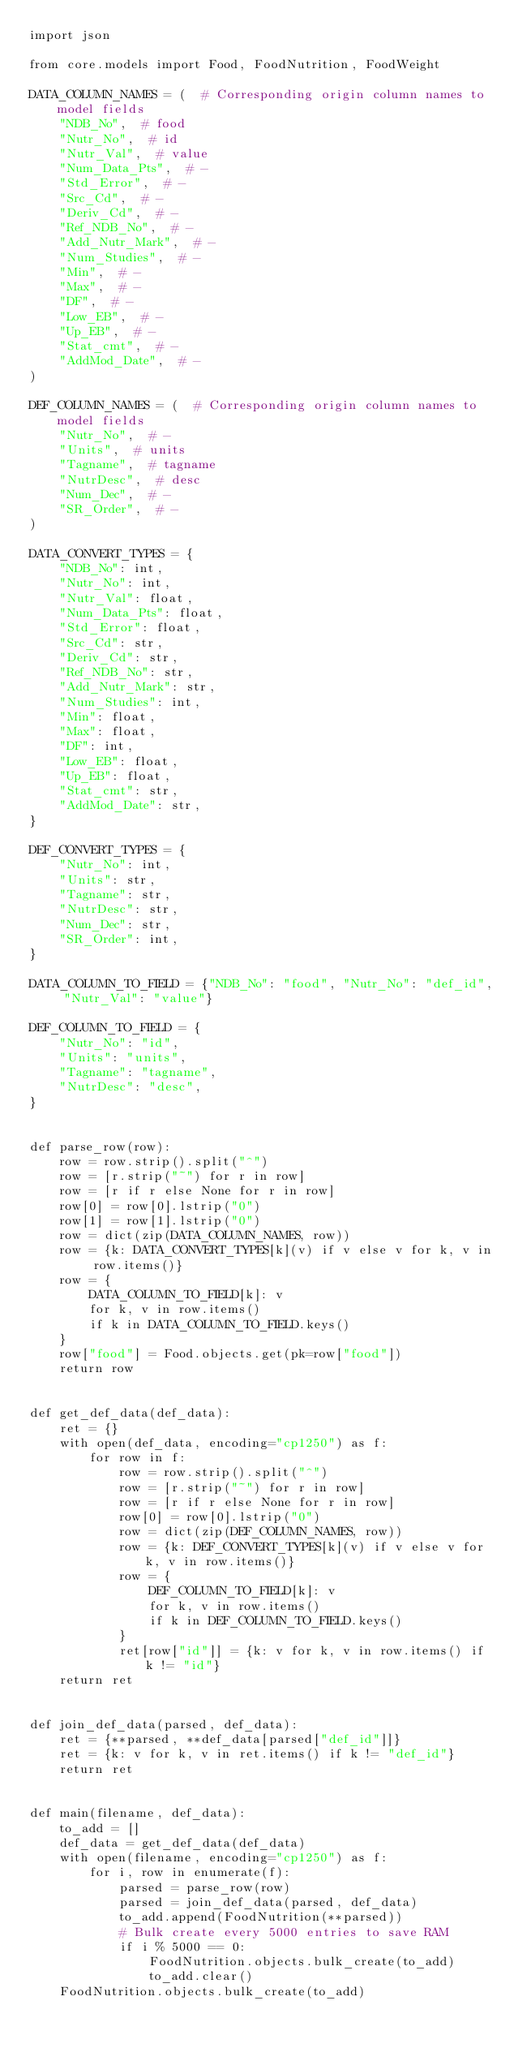<code> <loc_0><loc_0><loc_500><loc_500><_Python_>import json

from core.models import Food, FoodNutrition, FoodWeight

DATA_COLUMN_NAMES = (  # Corresponding origin column names to model fields
    "NDB_No",  # food
    "Nutr_No",  # id
    "Nutr_Val",  # value
    "Num_Data_Pts",  # -
    "Std_Error",  # -
    "Src_Cd",  # -
    "Deriv_Cd",  # -
    "Ref_NDB_No",  # -
    "Add_Nutr_Mark",  # -
    "Num_Studies",  # -
    "Min",  # -
    "Max",  # -
    "DF",  # -
    "Low_EB",  # -
    "Up_EB",  # -
    "Stat_cmt",  # -
    "AddMod_Date",  # -
)

DEF_COLUMN_NAMES = (  # Corresponding origin column names to model fields
    "Nutr_No",  # -
    "Units",  # units
    "Tagname",  # tagname
    "NutrDesc",  # desc
    "Num_Dec",  # -
    "SR_Order",  # -
)

DATA_CONVERT_TYPES = {
    "NDB_No": int,
    "Nutr_No": int,
    "Nutr_Val": float,
    "Num_Data_Pts": float,
    "Std_Error": float,
    "Src_Cd": str,
    "Deriv_Cd": str,
    "Ref_NDB_No": str,
    "Add_Nutr_Mark": str,
    "Num_Studies": int,
    "Min": float,
    "Max": float,
    "DF": int,
    "Low_EB": float,
    "Up_EB": float,
    "Stat_cmt": str,
    "AddMod_Date": str,
}

DEF_CONVERT_TYPES = {
    "Nutr_No": int,
    "Units": str,
    "Tagname": str,
    "NutrDesc": str,
    "Num_Dec": str,
    "SR_Order": int,
}

DATA_COLUMN_TO_FIELD = {"NDB_No": "food", "Nutr_No": "def_id", "Nutr_Val": "value"}

DEF_COLUMN_TO_FIELD = {
    "Nutr_No": "id",
    "Units": "units",
    "Tagname": "tagname",
    "NutrDesc": "desc",
}


def parse_row(row):
    row = row.strip().split("^")
    row = [r.strip("~") for r in row]
    row = [r if r else None for r in row]
    row[0] = row[0].lstrip("0")
    row[1] = row[1].lstrip("0")
    row = dict(zip(DATA_COLUMN_NAMES, row))
    row = {k: DATA_CONVERT_TYPES[k](v) if v else v for k, v in row.items()}
    row = {
        DATA_COLUMN_TO_FIELD[k]: v
        for k, v in row.items()
        if k in DATA_COLUMN_TO_FIELD.keys()
    }
    row["food"] = Food.objects.get(pk=row["food"])
    return row


def get_def_data(def_data):
    ret = {}
    with open(def_data, encoding="cp1250") as f:
        for row in f:
            row = row.strip().split("^")
            row = [r.strip("~") for r in row]
            row = [r if r else None for r in row]
            row[0] = row[0].lstrip("0")
            row = dict(zip(DEF_COLUMN_NAMES, row))
            row = {k: DEF_CONVERT_TYPES[k](v) if v else v for k, v in row.items()}
            row = {
                DEF_COLUMN_TO_FIELD[k]: v
                for k, v in row.items()
                if k in DEF_COLUMN_TO_FIELD.keys()
            }
            ret[row["id"]] = {k: v for k, v in row.items() if k != "id"}
    return ret


def join_def_data(parsed, def_data):
    ret = {**parsed, **def_data[parsed["def_id"]]}
    ret = {k: v for k, v in ret.items() if k != "def_id"}
    return ret


def main(filename, def_data):
    to_add = []
    def_data = get_def_data(def_data)
    with open(filename, encoding="cp1250") as f:
        for i, row in enumerate(f):
            parsed = parse_row(row)
            parsed = join_def_data(parsed, def_data)
            to_add.append(FoodNutrition(**parsed))
            # Bulk create every 5000 entries to save RAM
            if i % 5000 == 0:
                FoodNutrition.objects.bulk_create(to_add)
                to_add.clear()
    FoodNutrition.objects.bulk_create(to_add)
</code> 